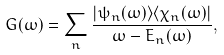<formula> <loc_0><loc_0><loc_500><loc_500>G ( \omega ) = \sum _ { n } \frac { | \psi _ { n } ( \omega ) \rangle \langle \chi _ { n } ( \omega ) | } { \omega - E _ { n } ( \omega ) } ,</formula> 